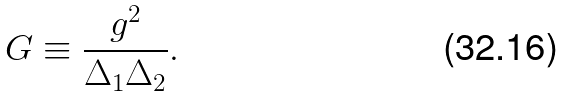Convert formula to latex. <formula><loc_0><loc_0><loc_500><loc_500>G \equiv \frac { g ^ { 2 } } { \Delta _ { 1 } \Delta _ { 2 } } .</formula> 